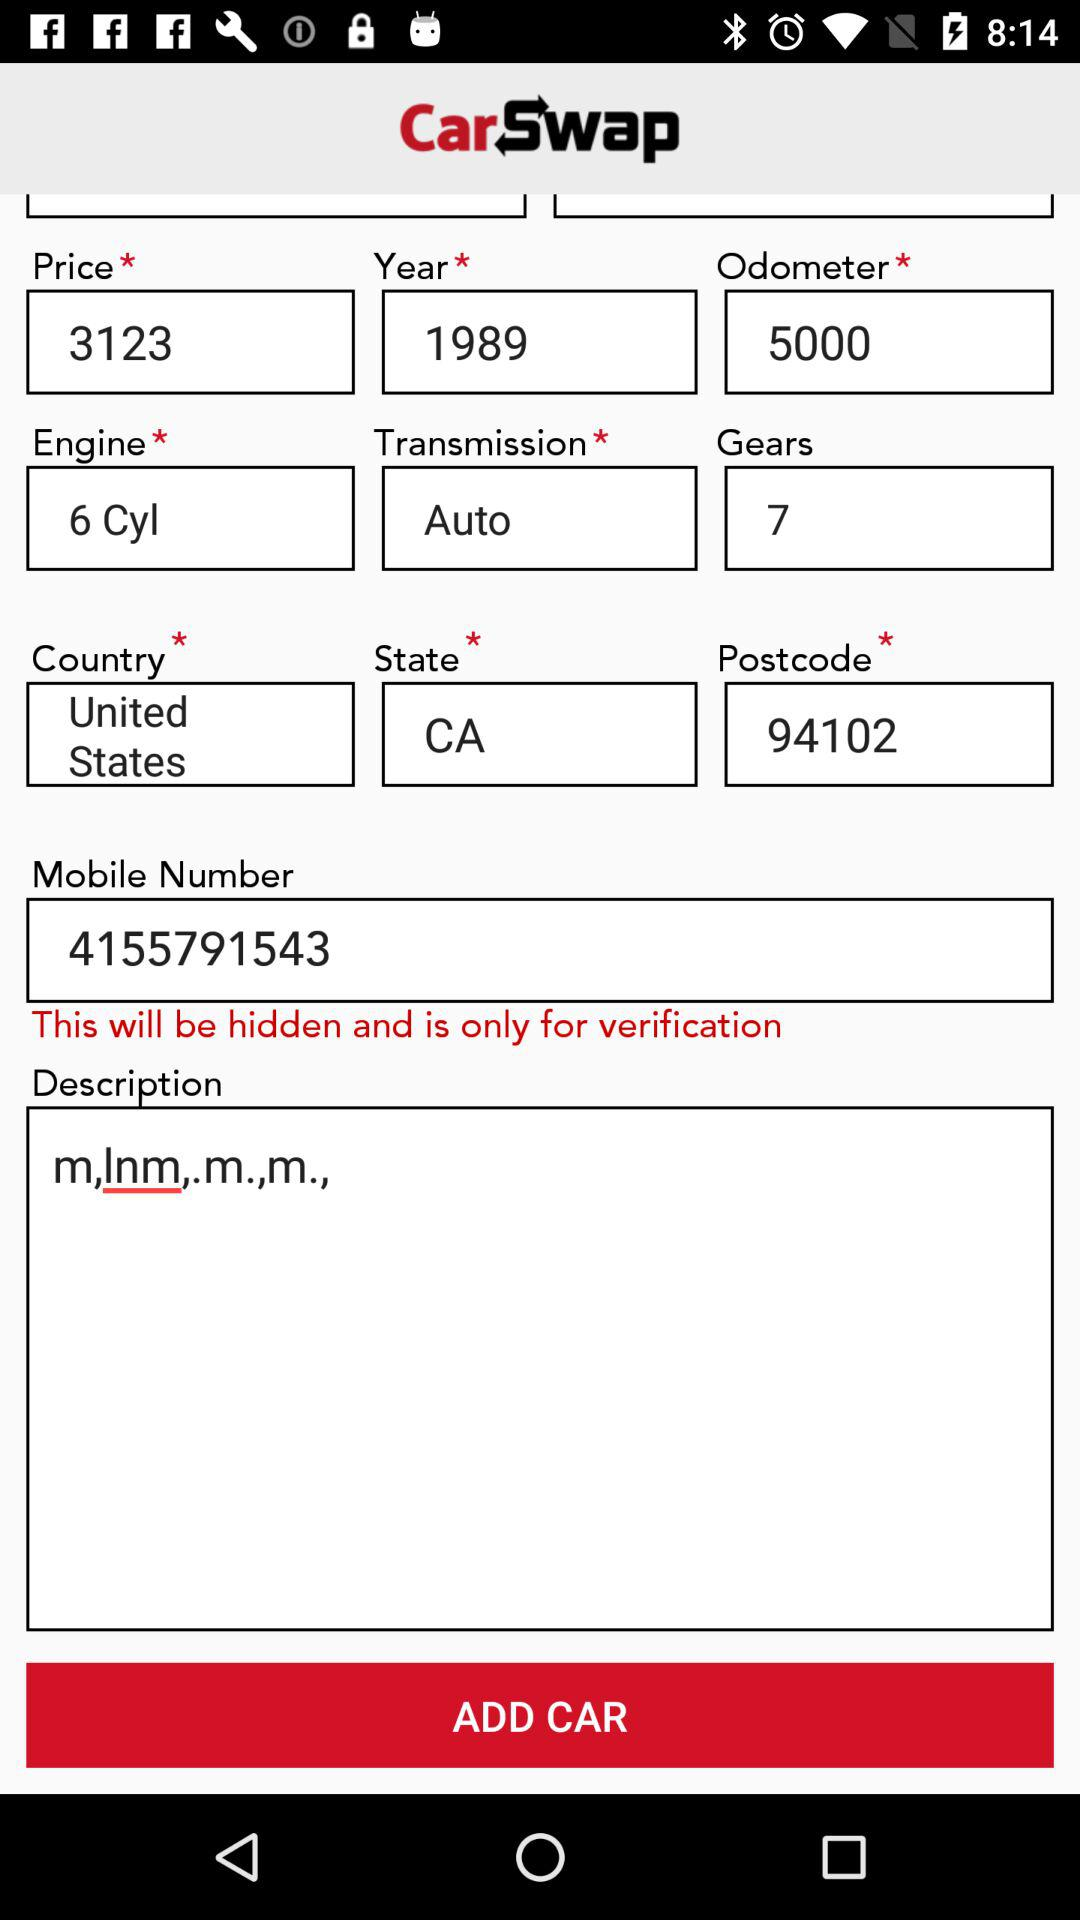What is the "Price"? The "Price" is 3123. 